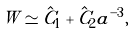Convert formula to latex. <formula><loc_0><loc_0><loc_500><loc_500>W \simeq \hat { C } _ { 1 } + \hat { C } _ { 2 } a ^ { - 3 } ,</formula> 